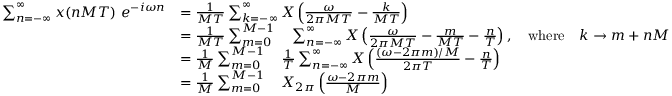Convert formula to latex. <formula><loc_0><loc_0><loc_500><loc_500>{ \begin{array} { r l } { \sum _ { n = - \infty } ^ { \infty } x ( n M T ) \ e ^ { - i \omega n } } & { = { \frac { 1 } { M T } } \sum _ { k = - \infty } ^ { \infty } X \left ( { \frac { \omega } { 2 \pi M T } } - { \frac { k } { M T } } \right ) } \\ & { = { \frac { 1 } { M T } } \sum _ { m = 0 } ^ { M - 1 } \quad \sum _ { n = - \infty } ^ { \infty } X \left ( { \frac { \omega } { 2 \pi M T } } - { \frac { m } { M T } } - { \frac { n } { T } } \right ) , \quad w h e r e \quad k \rightarrow m + n M } \\ & { = { \frac { 1 } { M } } \sum _ { m = 0 } ^ { M - 1 } \quad \frac { 1 } { T } \sum _ { n = - \infty } ^ { \infty } X \left ( { \frac { ( \omega - 2 \pi m ) / M } { 2 \pi T } } - { \frac { n } { T } } \right ) } \\ & { = { \frac { 1 } { M } } \sum _ { m = 0 } ^ { M - 1 } \quad X _ { 2 \pi } \left ( { \frac { \omega - 2 \pi m } { M } } \right ) } \end{array} }</formula> 